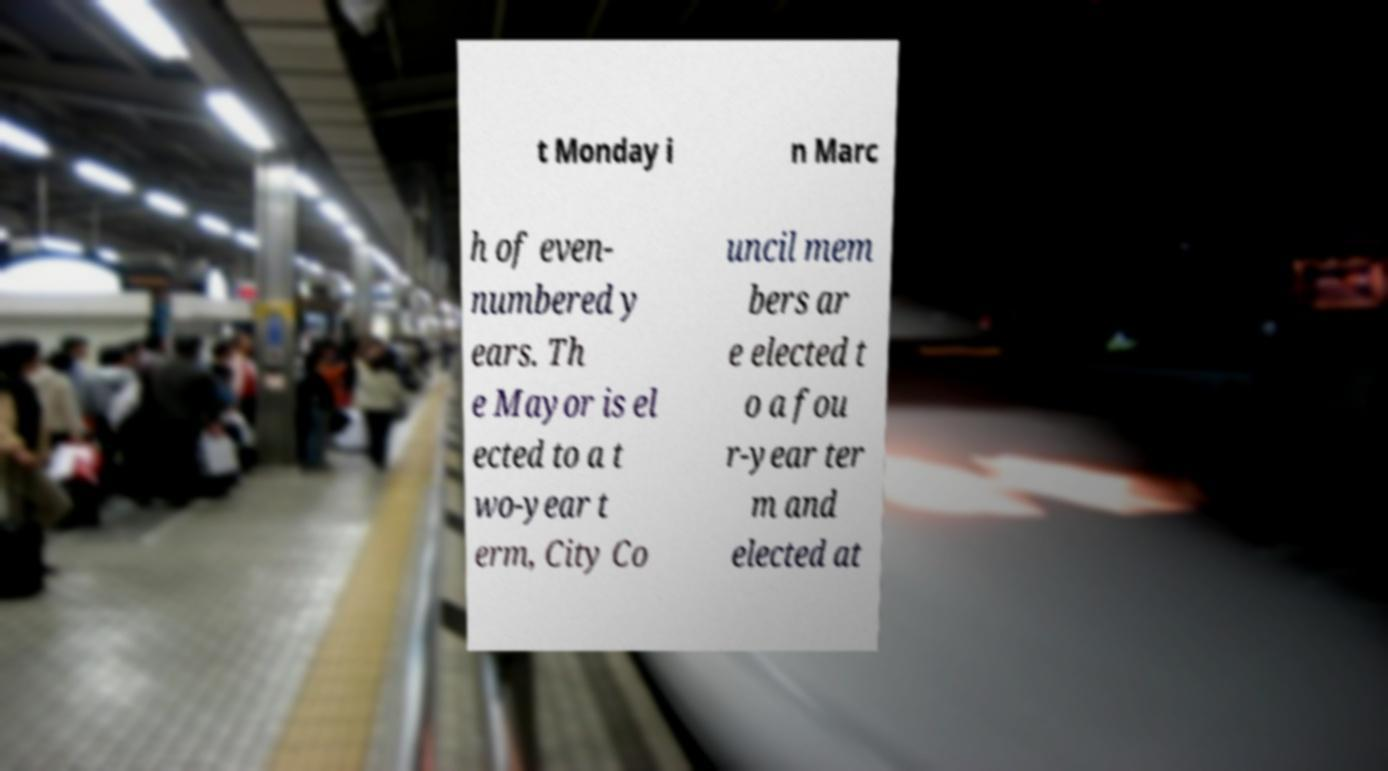Could you extract and type out the text from this image? t Monday i n Marc h of even- numbered y ears. Th e Mayor is el ected to a t wo-year t erm, City Co uncil mem bers ar e elected t o a fou r-year ter m and elected at 